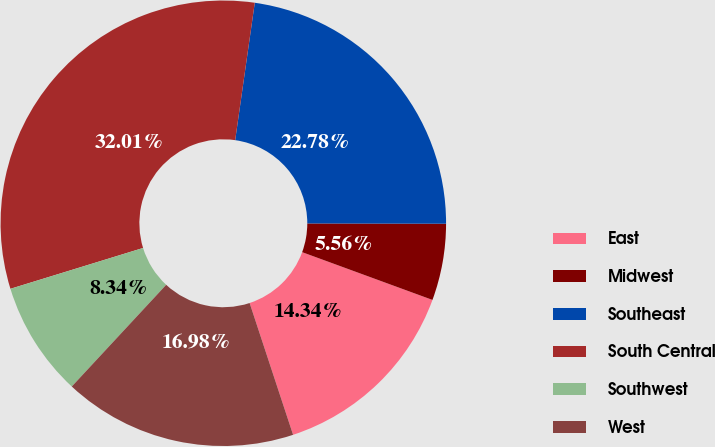<chart> <loc_0><loc_0><loc_500><loc_500><pie_chart><fcel>East<fcel>Midwest<fcel>Southeast<fcel>South Central<fcel>Southwest<fcel>West<nl><fcel>14.34%<fcel>5.56%<fcel>22.78%<fcel>32.01%<fcel>8.34%<fcel>16.98%<nl></chart> 